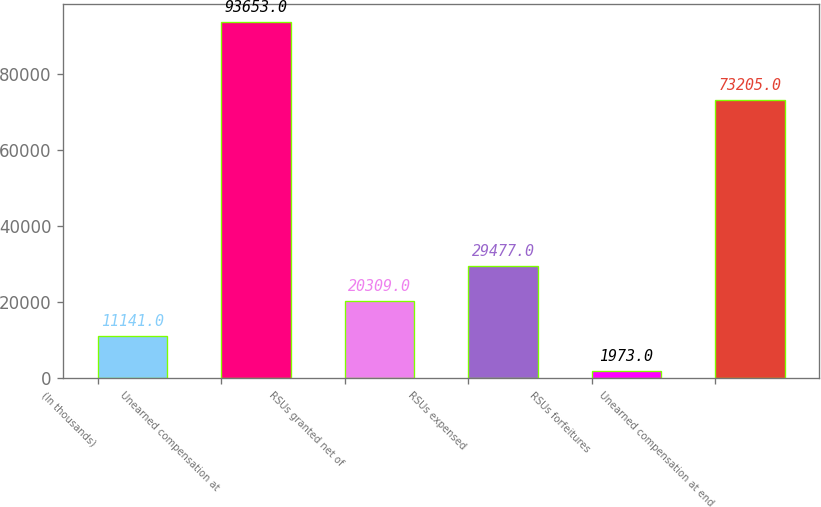Convert chart to OTSL. <chart><loc_0><loc_0><loc_500><loc_500><bar_chart><fcel>(In thousands)<fcel>Unearned compensation at<fcel>RSUs granted net of<fcel>RSUs expensed<fcel>RSUs forfeitures<fcel>Unearned compensation at end<nl><fcel>11141<fcel>93653<fcel>20309<fcel>29477<fcel>1973<fcel>73205<nl></chart> 